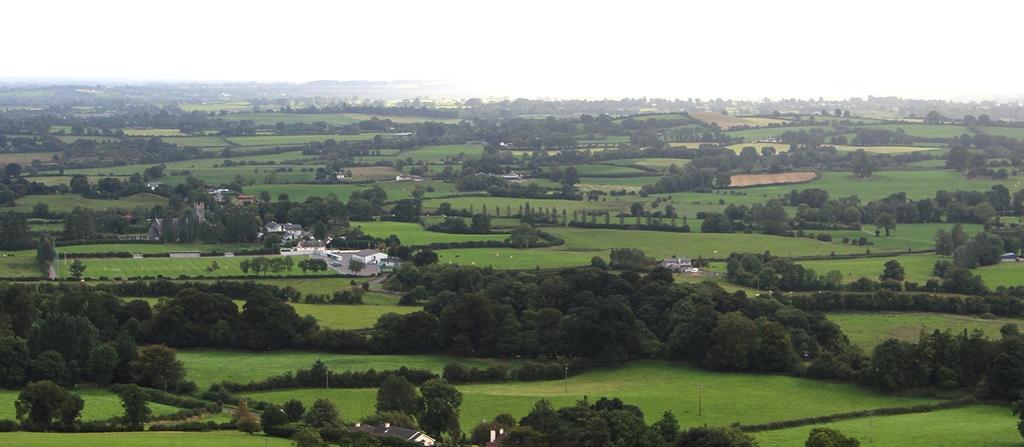In one or two sentences, can you explain what this image depicts? This picture is clicked in the outskirts. At the bottom of the picture, there are many trees and we even see poles. In the middle of the picture, we see buildings which are in white and brown color and we even see grass. There are many trees and hills in the background. At the top of the picture, we see the sky. 